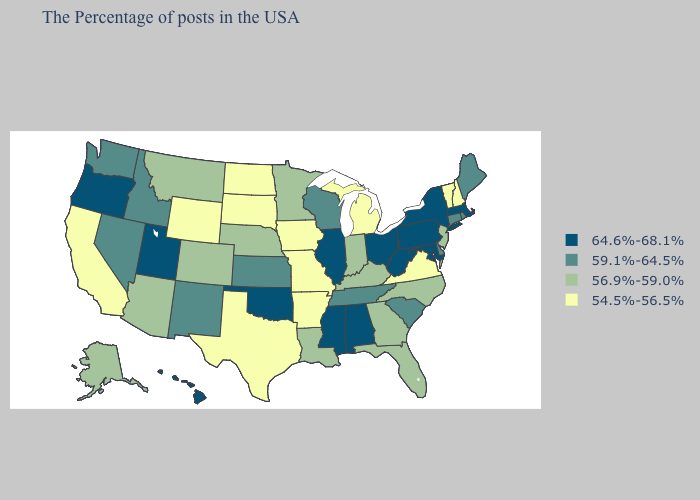What is the lowest value in the USA?
Quick response, please. 54.5%-56.5%. Name the states that have a value in the range 64.6%-68.1%?
Short answer required. Massachusetts, New York, Maryland, Pennsylvania, West Virginia, Ohio, Alabama, Illinois, Mississippi, Oklahoma, Utah, Oregon, Hawaii. Name the states that have a value in the range 54.5%-56.5%?
Give a very brief answer. New Hampshire, Vermont, Virginia, Michigan, Missouri, Arkansas, Iowa, Texas, South Dakota, North Dakota, Wyoming, California. Does California have the highest value in the USA?
Write a very short answer. No. What is the value of New Jersey?
Keep it brief. 56.9%-59.0%. Name the states that have a value in the range 59.1%-64.5%?
Concise answer only. Maine, Rhode Island, Connecticut, Delaware, South Carolina, Tennessee, Wisconsin, Kansas, New Mexico, Idaho, Nevada, Washington. What is the value of South Carolina?
Quick response, please. 59.1%-64.5%. Does Wisconsin have a higher value than Indiana?
Keep it brief. Yes. Among the states that border North Dakota , does South Dakota have the lowest value?
Give a very brief answer. Yes. Name the states that have a value in the range 59.1%-64.5%?
Write a very short answer. Maine, Rhode Island, Connecticut, Delaware, South Carolina, Tennessee, Wisconsin, Kansas, New Mexico, Idaho, Nevada, Washington. What is the value of New Hampshire?
Quick response, please. 54.5%-56.5%. Name the states that have a value in the range 54.5%-56.5%?
Be succinct. New Hampshire, Vermont, Virginia, Michigan, Missouri, Arkansas, Iowa, Texas, South Dakota, North Dakota, Wyoming, California. What is the highest value in the Northeast ?
Answer briefly. 64.6%-68.1%. What is the value of Nevada?
Short answer required. 59.1%-64.5%. What is the lowest value in states that border North Carolina?
Answer briefly. 54.5%-56.5%. 